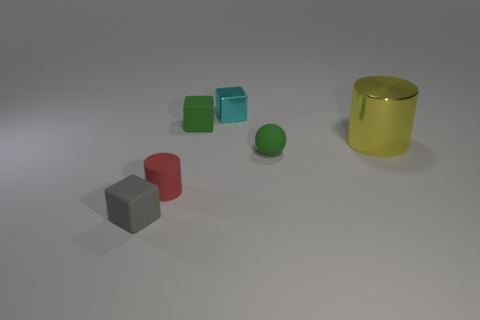Are there any other tiny objects of the same shape as the tiny shiny thing?
Your response must be concise. Yes. There is a small matte object that is to the right of the metal thing that is behind the big shiny object; what shape is it?
Ensure brevity in your answer.  Sphere. What shape is the small red matte thing?
Ensure brevity in your answer.  Cylinder. What is the green object that is behind the green rubber thing that is right of the metallic thing to the left of the big yellow metallic thing made of?
Provide a succinct answer. Rubber. How many other things are the same material as the green ball?
Your answer should be compact. 3. How many matte cubes are in front of the object that is to the left of the tiny cylinder?
Offer a terse response. 0. How many spheres are big yellow things or cyan shiny things?
Offer a terse response. 0. What color is the thing that is both on the right side of the small cyan cube and in front of the shiny cylinder?
Provide a succinct answer. Green. Is there any other thing that is the same color as the sphere?
Your response must be concise. Yes. What is the color of the small thing that is behind the matte block that is behind the gray rubber object?
Provide a short and direct response. Cyan. 